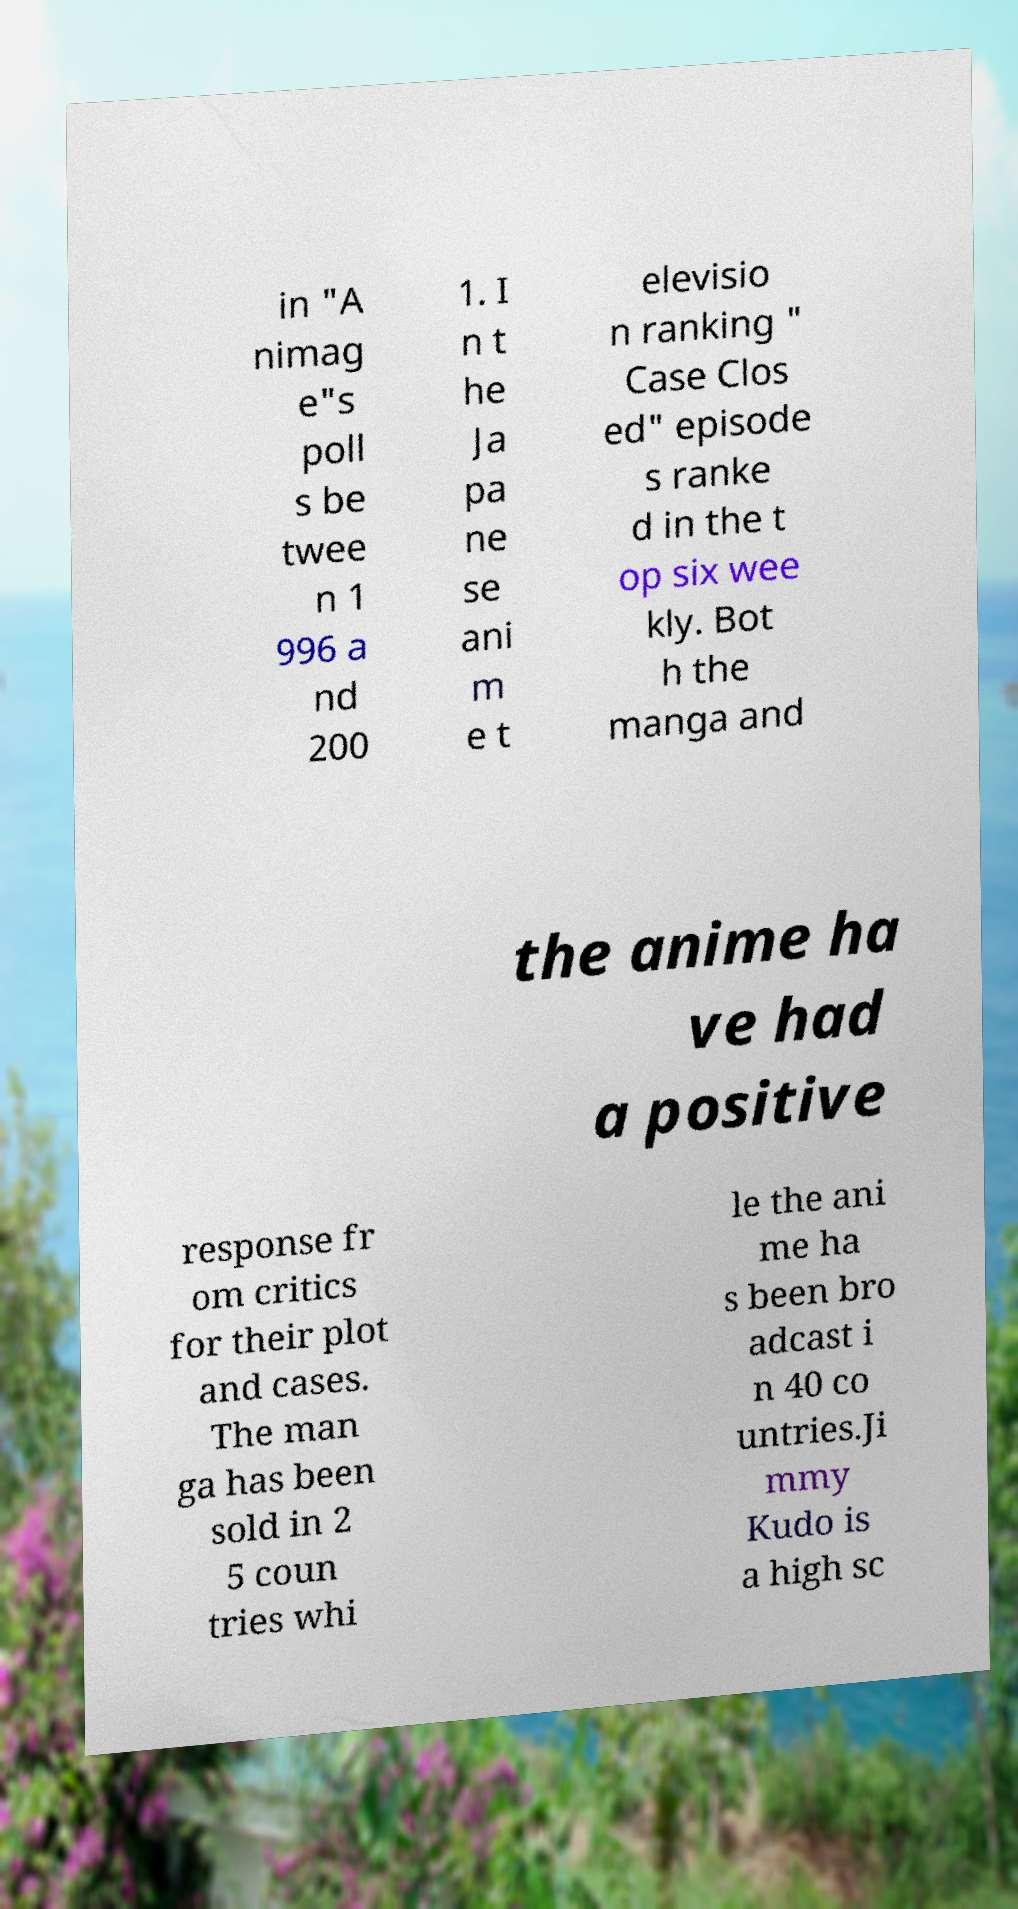Could you assist in decoding the text presented in this image and type it out clearly? in "A nimag e"s poll s be twee n 1 996 a nd 200 1. I n t he Ja pa ne se ani m e t elevisio n ranking " Case Clos ed" episode s ranke d in the t op six wee kly. Bot h the manga and the anime ha ve had a positive response fr om critics for their plot and cases. The man ga has been sold in 2 5 coun tries whi le the ani me ha s been bro adcast i n 40 co untries.Ji mmy Kudo is a high sc 